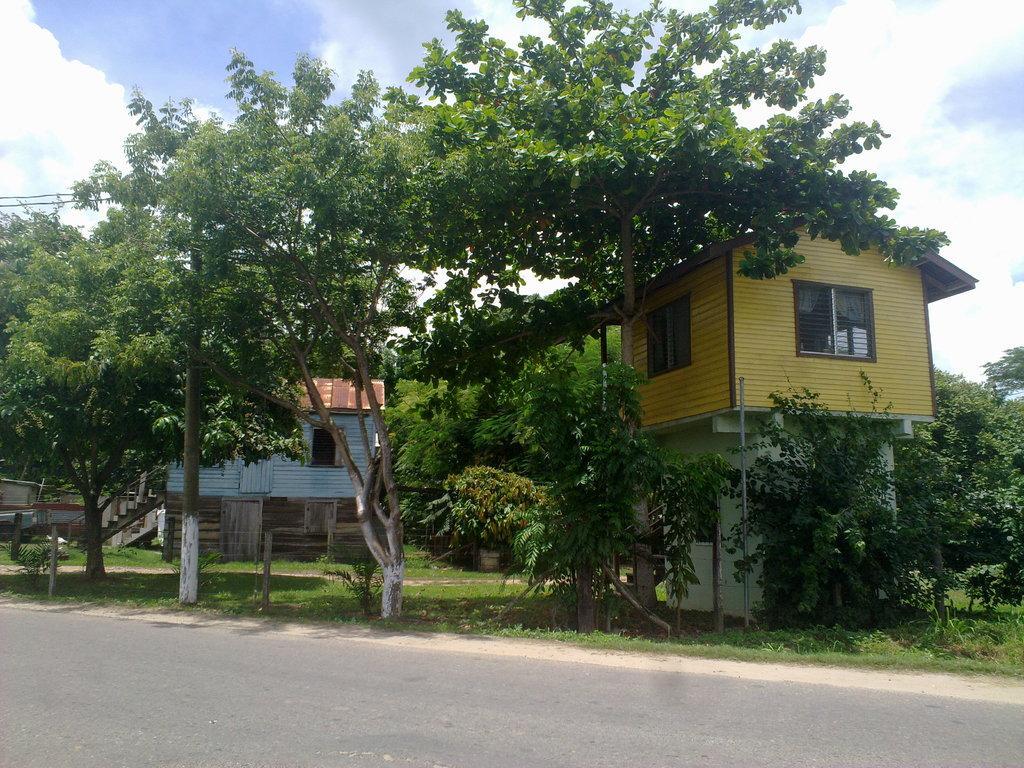In one or two sentences, can you explain what this image depicts? This image consists of grass, plants, trees, poles, houses, vehicle on the road and the sky. This image is taken may be during a day. 